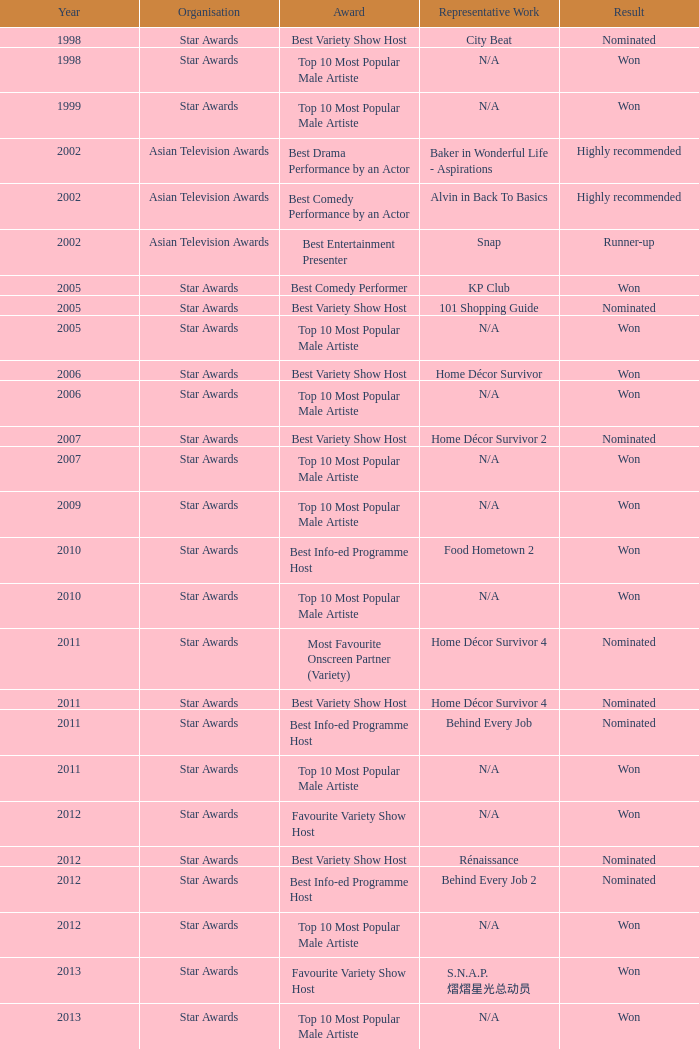What is the prize for the star awards before 2005 and the outcome is victorious? Top 10 Most Popular Male Artiste, Top 10 Most Popular Male Artiste. 